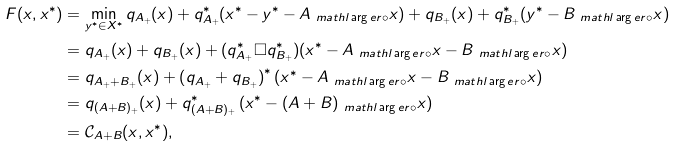Convert formula to latex. <formula><loc_0><loc_0><loc_500><loc_500>F ( x , x ^ { * } ) & = \min _ { y ^ { * } \in X ^ { * } } q _ { A _ { + } } ( x ) + q _ { A _ { + } } ^ { * } ( x ^ { * } - y ^ { * } - A _ { \ m a t h l \arg e r \circ } x ) + q _ { B _ { + } } ( x ) + q _ { B _ { + } } ^ { * } ( y ^ { * } - B _ { \ m a t h l \arg e r \circ } x ) \\ & = q _ { A _ { + } } ( x ) + q _ { B _ { + } } ( x ) + ( q _ { A _ { + } } ^ { * } \Box q _ { B _ { + } } ^ { * } ) ( x ^ { * } - A _ { \ m a t h l \arg e r \circ } x - B _ { \ m a t h l \arg e r \circ } x ) \\ & = q _ { A _ { + } + B _ { + } } ( x ) + \left ( q _ { A _ { + } } + q _ { B _ { + } } \right ) ^ { * } ( x ^ { * } - A _ { \ m a t h l \arg e r \circ } x - B _ { \ m a t h l \arg e r \circ } x ) \\ & = q _ { ( A + B ) _ { + } } ( x ) + q _ { ( A + B ) _ { + } } ^ { * } \left ( x ^ { * } - ( A + B ) _ { \ m a t h l \arg e r \circ } x \right ) \\ & = \mathcal { C } _ { A + B } ( x , x ^ { * } ) ,</formula> 